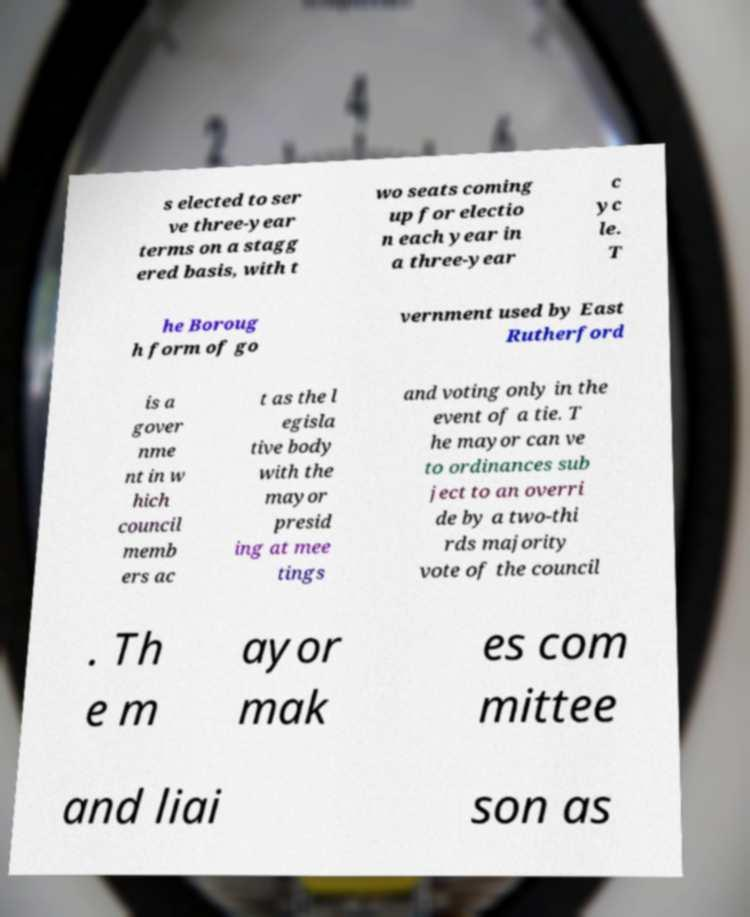Can you accurately transcribe the text from the provided image for me? s elected to ser ve three-year terms on a stagg ered basis, with t wo seats coming up for electio n each year in a three-year c yc le. T he Boroug h form of go vernment used by East Rutherford is a gover nme nt in w hich council memb ers ac t as the l egisla tive body with the mayor presid ing at mee tings and voting only in the event of a tie. T he mayor can ve to ordinances sub ject to an overri de by a two-thi rds majority vote of the council . Th e m ayor mak es com mittee and liai son as 